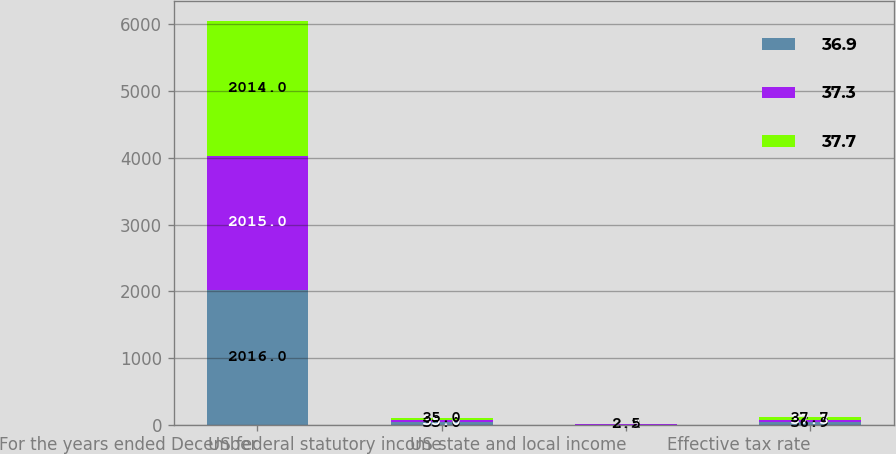Convert chart to OTSL. <chart><loc_0><loc_0><loc_500><loc_500><stacked_bar_chart><ecel><fcel>For the years ended December<fcel>US federal statutory income<fcel>US state and local income<fcel>Effective tax rate<nl><fcel>36.9<fcel>2016<fcel>35<fcel>2.2<fcel>36.9<nl><fcel>37.3<fcel>2015<fcel>35<fcel>2.3<fcel>37.3<nl><fcel>37.7<fcel>2014<fcel>35<fcel>2.5<fcel>37.7<nl></chart> 